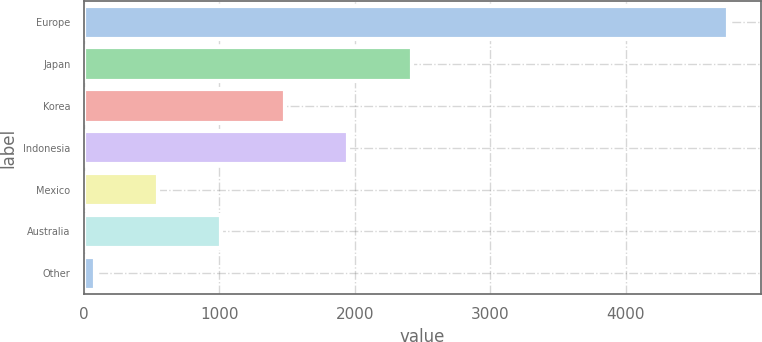Convert chart. <chart><loc_0><loc_0><loc_500><loc_500><bar_chart><fcel>Europe<fcel>Japan<fcel>Korea<fcel>Indonesia<fcel>Mexico<fcel>Australia<fcel>Other<nl><fcel>4756<fcel>2418.5<fcel>1483.5<fcel>1951<fcel>548.5<fcel>1016<fcel>81<nl></chart> 